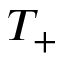Convert formula to latex. <formula><loc_0><loc_0><loc_500><loc_500>T _ { + }</formula> 